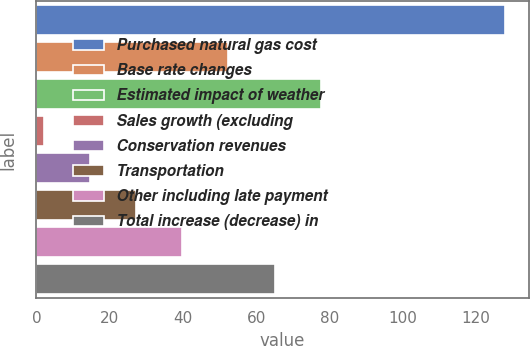Convert chart to OTSL. <chart><loc_0><loc_0><loc_500><loc_500><bar_chart><fcel>Purchased natural gas cost<fcel>Base rate changes<fcel>Estimated impact of weather<fcel>Sales growth (excluding<fcel>Conservation revenues<fcel>Transportation<fcel>Other including late payment<fcel>Total increase (decrease) in<nl><fcel>128<fcel>52.4<fcel>77.6<fcel>2<fcel>14.6<fcel>27.2<fcel>39.8<fcel>65<nl></chart> 